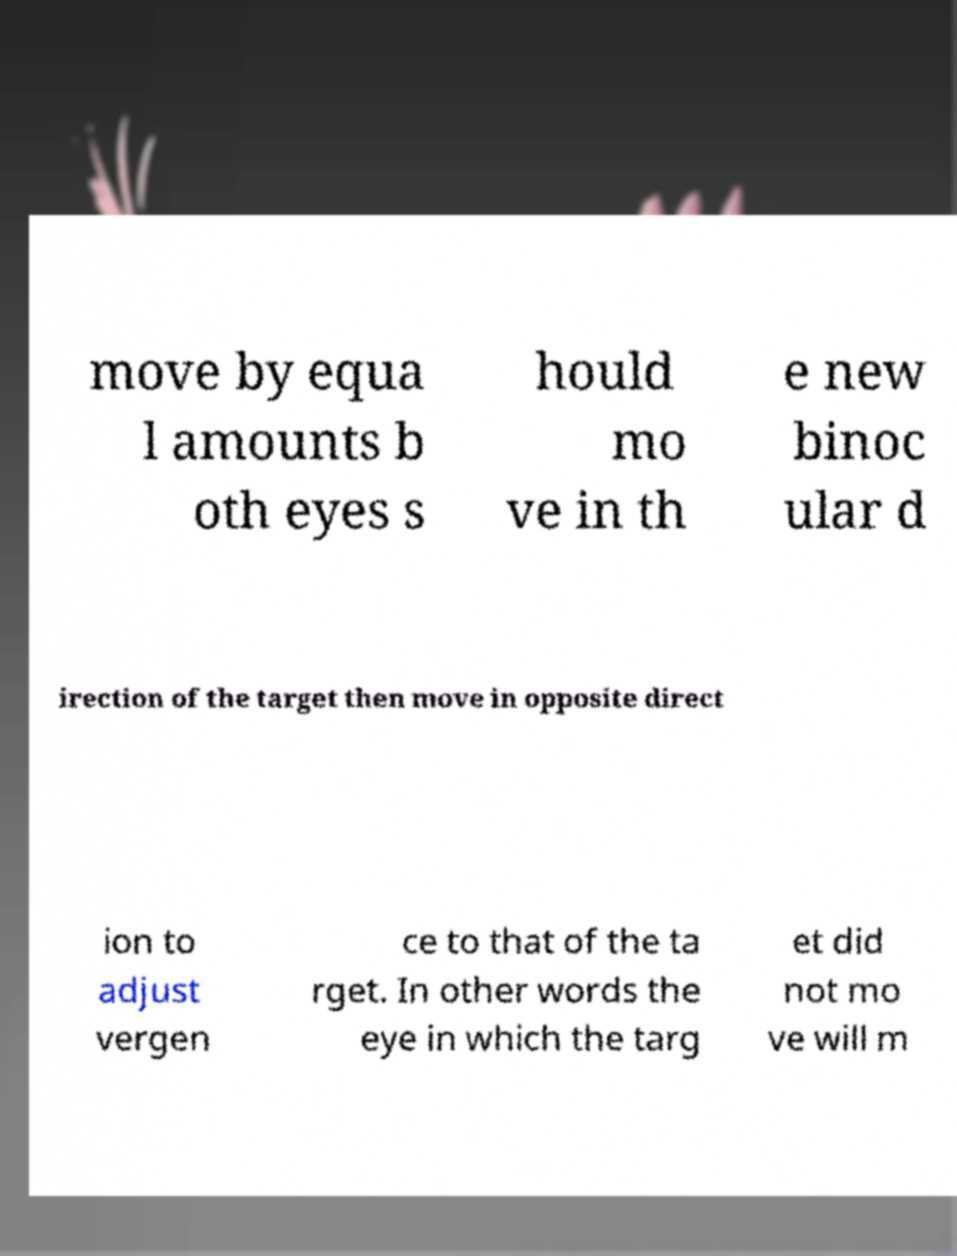Can you read and provide the text displayed in the image?This photo seems to have some interesting text. Can you extract and type it out for me? move by equa l amounts b oth eyes s hould mo ve in th e new binoc ular d irection of the target then move in opposite direct ion to adjust vergen ce to that of the ta rget. In other words the eye in which the targ et did not mo ve will m 